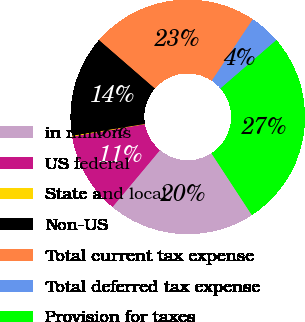Convert chart. <chart><loc_0><loc_0><loc_500><loc_500><pie_chart><fcel>in millions<fcel>US federal<fcel>State and local<fcel>Non-US<fcel>Total current tax expense<fcel>Total deferred tax expense<fcel>Provision for taxes<nl><fcel>20.29%<fcel>11.24%<fcel>0.12%<fcel>13.94%<fcel>22.99%<fcel>4.28%<fcel>27.14%<nl></chart> 